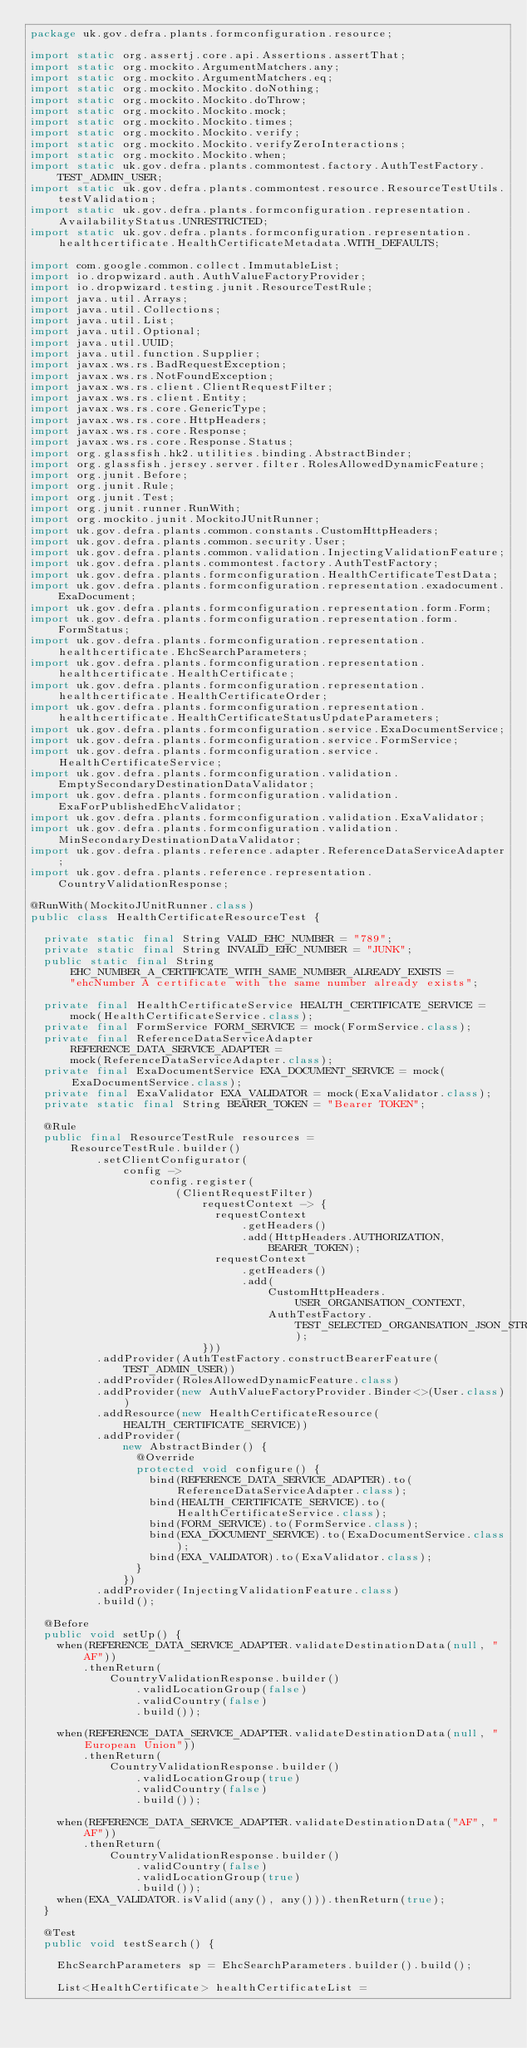<code> <loc_0><loc_0><loc_500><loc_500><_Java_>package uk.gov.defra.plants.formconfiguration.resource;

import static org.assertj.core.api.Assertions.assertThat;
import static org.mockito.ArgumentMatchers.any;
import static org.mockito.ArgumentMatchers.eq;
import static org.mockito.Mockito.doNothing;
import static org.mockito.Mockito.doThrow;
import static org.mockito.Mockito.mock;
import static org.mockito.Mockito.times;
import static org.mockito.Mockito.verify;
import static org.mockito.Mockito.verifyZeroInteractions;
import static org.mockito.Mockito.when;
import static uk.gov.defra.plants.commontest.factory.AuthTestFactory.TEST_ADMIN_USER;
import static uk.gov.defra.plants.commontest.resource.ResourceTestUtils.testValidation;
import static uk.gov.defra.plants.formconfiguration.representation.AvailabilityStatus.UNRESTRICTED;
import static uk.gov.defra.plants.formconfiguration.representation.healthcertificate.HealthCertificateMetadata.WITH_DEFAULTS;

import com.google.common.collect.ImmutableList;
import io.dropwizard.auth.AuthValueFactoryProvider;
import io.dropwizard.testing.junit.ResourceTestRule;
import java.util.Arrays;
import java.util.Collections;
import java.util.List;
import java.util.Optional;
import java.util.UUID;
import java.util.function.Supplier;
import javax.ws.rs.BadRequestException;
import javax.ws.rs.NotFoundException;
import javax.ws.rs.client.ClientRequestFilter;
import javax.ws.rs.client.Entity;
import javax.ws.rs.core.GenericType;
import javax.ws.rs.core.HttpHeaders;
import javax.ws.rs.core.Response;
import javax.ws.rs.core.Response.Status;
import org.glassfish.hk2.utilities.binding.AbstractBinder;
import org.glassfish.jersey.server.filter.RolesAllowedDynamicFeature;
import org.junit.Before;
import org.junit.Rule;
import org.junit.Test;
import org.junit.runner.RunWith;
import org.mockito.junit.MockitoJUnitRunner;
import uk.gov.defra.plants.common.constants.CustomHttpHeaders;
import uk.gov.defra.plants.common.security.User;
import uk.gov.defra.plants.common.validation.InjectingValidationFeature;
import uk.gov.defra.plants.commontest.factory.AuthTestFactory;
import uk.gov.defra.plants.formconfiguration.HealthCertificateTestData;
import uk.gov.defra.plants.formconfiguration.representation.exadocument.ExaDocument;
import uk.gov.defra.plants.formconfiguration.representation.form.Form;
import uk.gov.defra.plants.formconfiguration.representation.form.FormStatus;
import uk.gov.defra.plants.formconfiguration.representation.healthcertificate.EhcSearchParameters;
import uk.gov.defra.plants.formconfiguration.representation.healthcertificate.HealthCertificate;
import uk.gov.defra.plants.formconfiguration.representation.healthcertificate.HealthCertificateOrder;
import uk.gov.defra.plants.formconfiguration.representation.healthcertificate.HealthCertificateStatusUpdateParameters;
import uk.gov.defra.plants.formconfiguration.service.ExaDocumentService;
import uk.gov.defra.plants.formconfiguration.service.FormService;
import uk.gov.defra.plants.formconfiguration.service.HealthCertificateService;
import uk.gov.defra.plants.formconfiguration.validation.EmptySecondaryDestinationDataValidator;
import uk.gov.defra.plants.formconfiguration.validation.ExaForPublishedEhcValidator;
import uk.gov.defra.plants.formconfiguration.validation.ExaValidator;
import uk.gov.defra.plants.formconfiguration.validation.MinSecondaryDestinationDataValidator;
import uk.gov.defra.plants.reference.adapter.ReferenceDataServiceAdapter;
import uk.gov.defra.plants.reference.representation.CountryValidationResponse;

@RunWith(MockitoJUnitRunner.class)
public class HealthCertificateResourceTest {

  private static final String VALID_EHC_NUMBER = "789";
  private static final String INVALID_EHC_NUMBER = "JUNK";
  public static final String EHC_NUMBER_A_CERTIFICATE_WITH_SAME_NUMBER_ALREADY_EXISTS =
      "ehcNumber A certificate with the same number already exists";

  private final HealthCertificateService HEALTH_CERTIFICATE_SERVICE =
      mock(HealthCertificateService.class);
  private final FormService FORM_SERVICE = mock(FormService.class);
  private final ReferenceDataServiceAdapter REFERENCE_DATA_SERVICE_ADAPTER =
      mock(ReferenceDataServiceAdapter.class);
  private final ExaDocumentService EXA_DOCUMENT_SERVICE = mock(ExaDocumentService.class);
  private final ExaValidator EXA_VALIDATOR = mock(ExaValidator.class);
  private static final String BEARER_TOKEN = "Bearer TOKEN";

  @Rule
  public final ResourceTestRule resources =
      ResourceTestRule.builder()
          .setClientConfigurator(
              config ->
                  config.register(
                      (ClientRequestFilter)
                          requestContext -> {
                            requestContext
                                .getHeaders()
                                .add(HttpHeaders.AUTHORIZATION, BEARER_TOKEN);
                            requestContext
                                .getHeaders()
                                .add(
                                    CustomHttpHeaders.USER_ORGANISATION_CONTEXT,
                                    AuthTestFactory.TEST_SELECTED_ORGANISATION_JSON_STRING);
                          }))
          .addProvider(AuthTestFactory.constructBearerFeature(TEST_ADMIN_USER))
          .addProvider(RolesAllowedDynamicFeature.class)
          .addProvider(new AuthValueFactoryProvider.Binder<>(User.class))
          .addResource(new HealthCertificateResource(HEALTH_CERTIFICATE_SERVICE))
          .addProvider(
              new AbstractBinder() {
                @Override
                protected void configure() {
                  bind(REFERENCE_DATA_SERVICE_ADAPTER).to(ReferenceDataServiceAdapter.class);
                  bind(HEALTH_CERTIFICATE_SERVICE).to(HealthCertificateService.class);
                  bind(FORM_SERVICE).to(FormService.class);
                  bind(EXA_DOCUMENT_SERVICE).to(ExaDocumentService.class);
                  bind(EXA_VALIDATOR).to(ExaValidator.class);
                }
              })
          .addProvider(InjectingValidationFeature.class)
          .build();

  @Before
  public void setUp() {
    when(REFERENCE_DATA_SERVICE_ADAPTER.validateDestinationData(null, "AF"))
        .thenReturn(
            CountryValidationResponse.builder()
                .validLocationGroup(false)
                .validCountry(false)
                .build());

    when(REFERENCE_DATA_SERVICE_ADAPTER.validateDestinationData(null, "European Union"))
        .thenReturn(
            CountryValidationResponse.builder()
                .validLocationGroup(true)
                .validCountry(false)
                .build());

    when(REFERENCE_DATA_SERVICE_ADAPTER.validateDestinationData("AF", "AF"))
        .thenReturn(
            CountryValidationResponse.builder()
                .validCountry(false)
                .validLocationGroup(true)
                .build());
    when(EXA_VALIDATOR.isValid(any(), any())).thenReturn(true);
  }

  @Test
  public void testSearch() {

    EhcSearchParameters sp = EhcSearchParameters.builder().build();

    List<HealthCertificate> healthCertificateList =</code> 